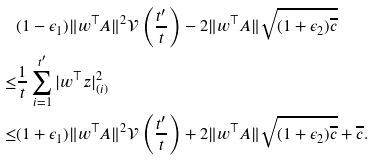Convert formula to latex. <formula><loc_0><loc_0><loc_500><loc_500>& ( 1 - \epsilon _ { 1 } ) \| w ^ { \top } A \| ^ { 2 } \mathcal { V } \left ( \frac { t ^ { \prime } } { t } \right ) - 2 \| w ^ { \top } A \| \sqrt { ( 1 + \epsilon _ { 2 } ) \overline { c } } \\ \leq & \frac { 1 } { t } \sum _ { i = 1 } ^ { t ^ { \prime } } | w ^ { \top } z | _ { ( i ) } ^ { 2 } \\ \leq & ( 1 + \epsilon _ { 1 } ) \| w ^ { \top } A \| ^ { 2 } \mathcal { V } \left ( \frac { t ^ { \prime } } { t } \right ) + 2 \| w ^ { \top } A \| \sqrt { ( 1 + \epsilon _ { 2 } ) \overline { c } } + \overline { c } .</formula> 